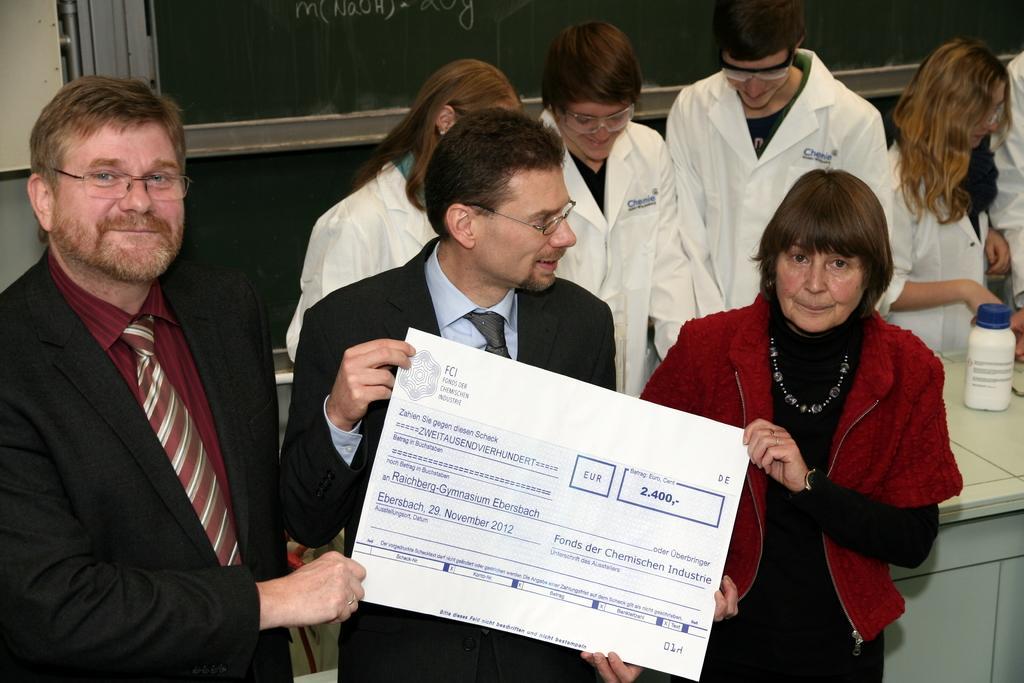Can you describe this image briefly? In this picture we can see three people and they are holding a paper and in the background we can see few people, bottle and some objects. 